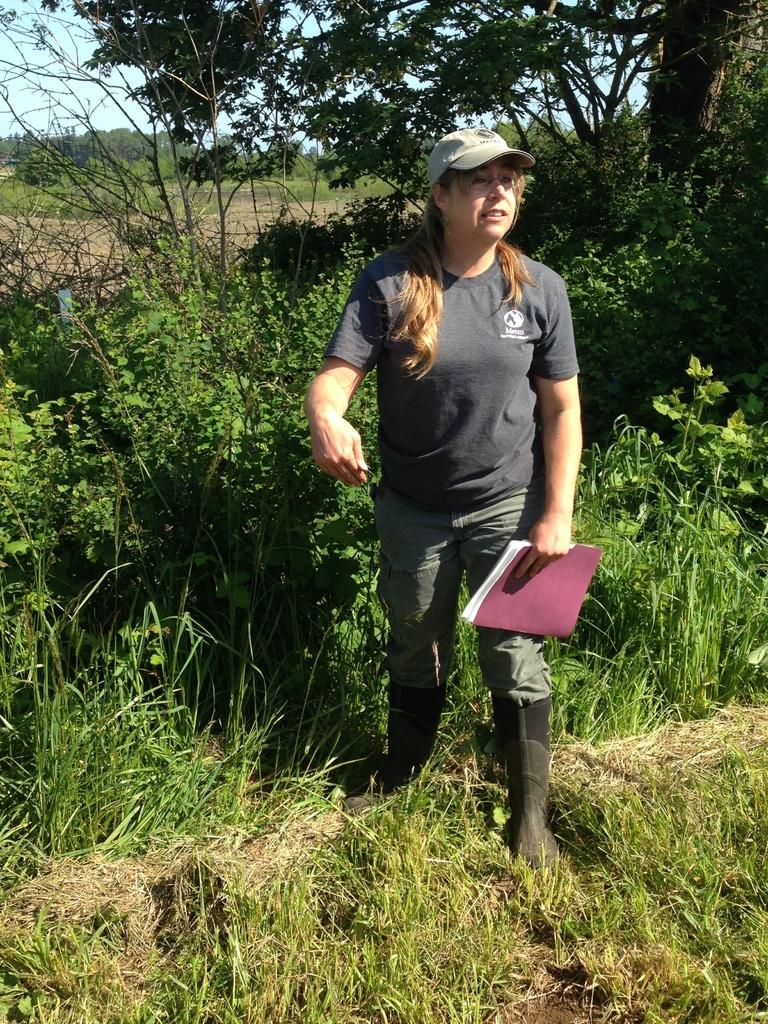Who is the main subject in the image? There is a lady in the image. What is the lady wearing on her head? The lady is wearing a cap. What is the lady holding in the image? The lady is holding a book. What type of vegetation can be seen in the image? There are many plants and trees in the image. What is visible in the background of the image? The sky is visible in the background of the image. What type of card is the lady holding in the image? The lady is not holding a card in the image; she is holding a book. 